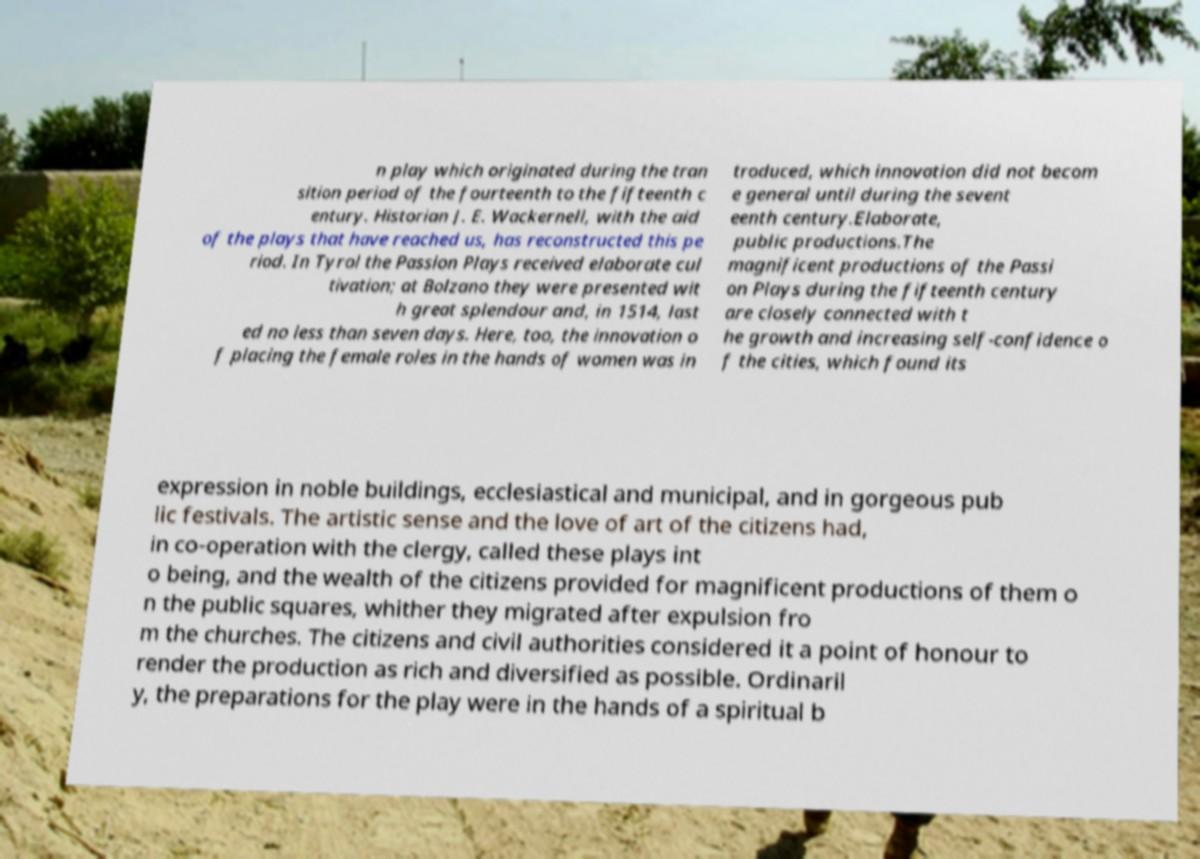Can you read and provide the text displayed in the image?This photo seems to have some interesting text. Can you extract and type it out for me? n play which originated during the tran sition period of the fourteenth to the fifteenth c entury. Historian J. E. Wackernell, with the aid of the plays that have reached us, has reconstructed this pe riod. In Tyrol the Passion Plays received elaborate cul tivation; at Bolzano they were presented wit h great splendour and, in 1514, last ed no less than seven days. Here, too, the innovation o f placing the female roles in the hands of women was in troduced, which innovation did not becom e general until during the sevent eenth century.Elaborate, public productions.The magnificent productions of the Passi on Plays during the fifteenth century are closely connected with t he growth and increasing self-confidence o f the cities, which found its expression in noble buildings, ecclesiastical and municipal, and in gorgeous pub lic festivals. The artistic sense and the love of art of the citizens had, in co-operation with the clergy, called these plays int o being, and the wealth of the citizens provided for magnificent productions of them o n the public squares, whither they migrated after expulsion fro m the churches. The citizens and civil authorities considered it a point of honour to render the production as rich and diversified as possible. Ordinaril y, the preparations for the play were in the hands of a spiritual b 